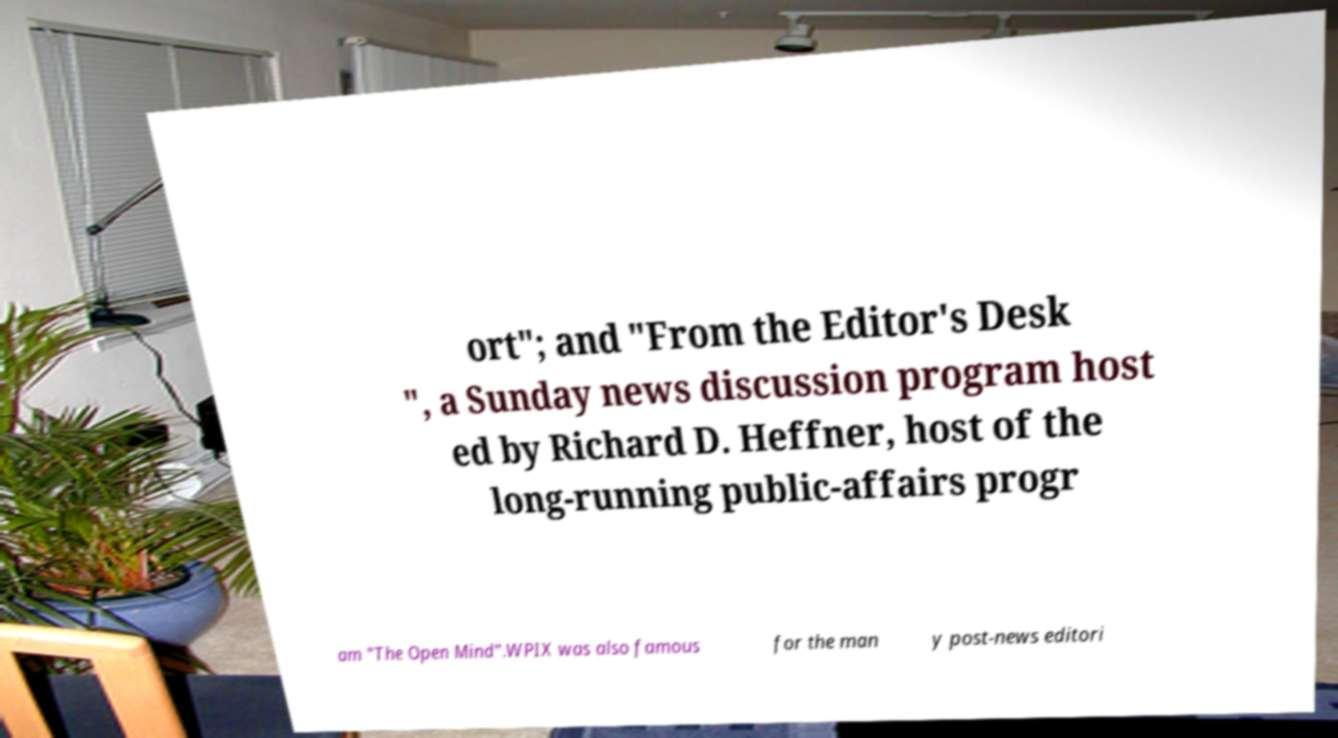Could you extract and type out the text from this image? ort"; and "From the Editor's Desk ", a Sunday news discussion program host ed by Richard D. Heffner, host of the long-running public-affairs progr am "The Open Mind".WPIX was also famous for the man y post-news editori 